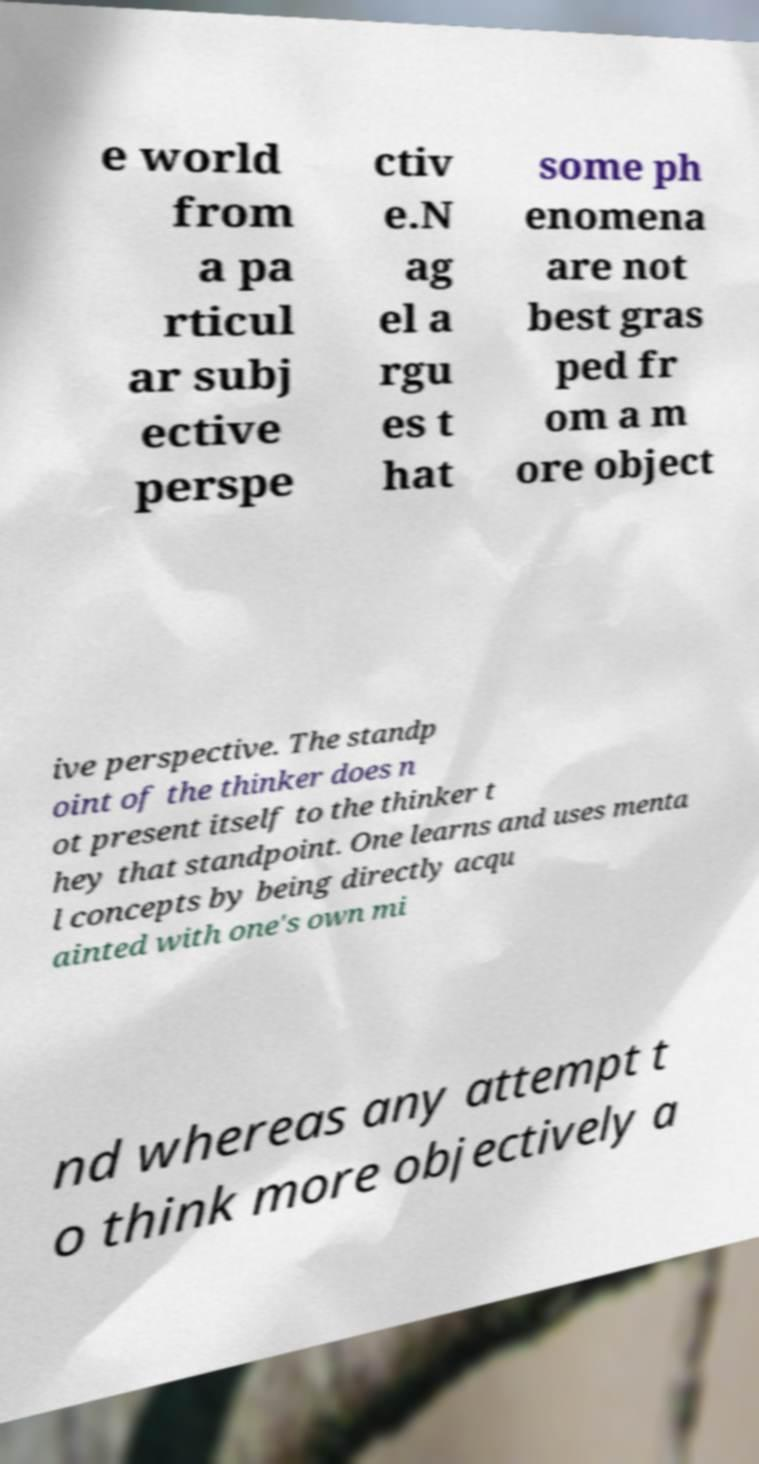I need the written content from this picture converted into text. Can you do that? e world from a pa rticul ar subj ective perspe ctiv e.N ag el a rgu es t hat some ph enomena are not best gras ped fr om a m ore object ive perspective. The standp oint of the thinker does n ot present itself to the thinker t hey that standpoint. One learns and uses menta l concepts by being directly acqu ainted with one's own mi nd whereas any attempt t o think more objectively a 